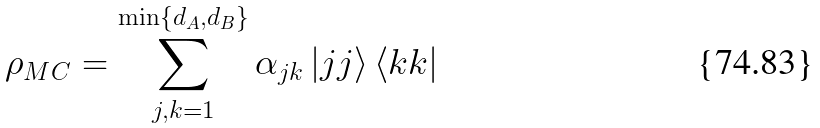Convert formula to latex. <formula><loc_0><loc_0><loc_500><loc_500>\rho _ { M C } = \sum _ { j , k = 1 } ^ { \min \{ d _ { A } , d _ { B } \} } \alpha _ { j k } \left | j j \right \rangle \left \langle k k \right |</formula> 